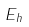<formula> <loc_0><loc_0><loc_500><loc_500>E _ { h }</formula> 